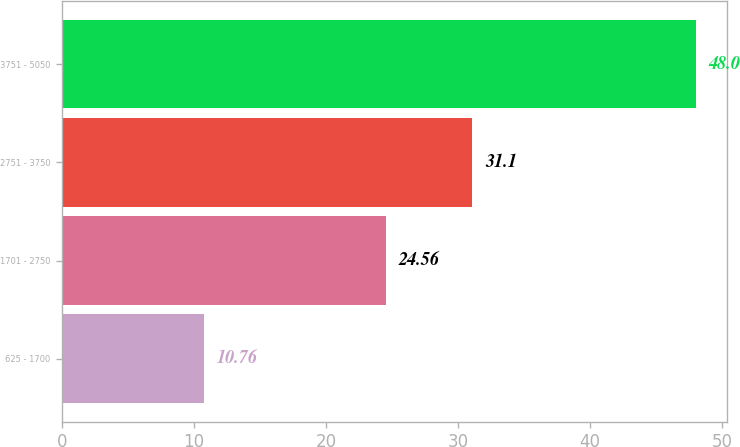Convert chart. <chart><loc_0><loc_0><loc_500><loc_500><bar_chart><fcel>625 - 1700<fcel>1701 - 2750<fcel>2751 - 3750<fcel>3751 - 5050<nl><fcel>10.76<fcel>24.56<fcel>31.1<fcel>48<nl></chart> 